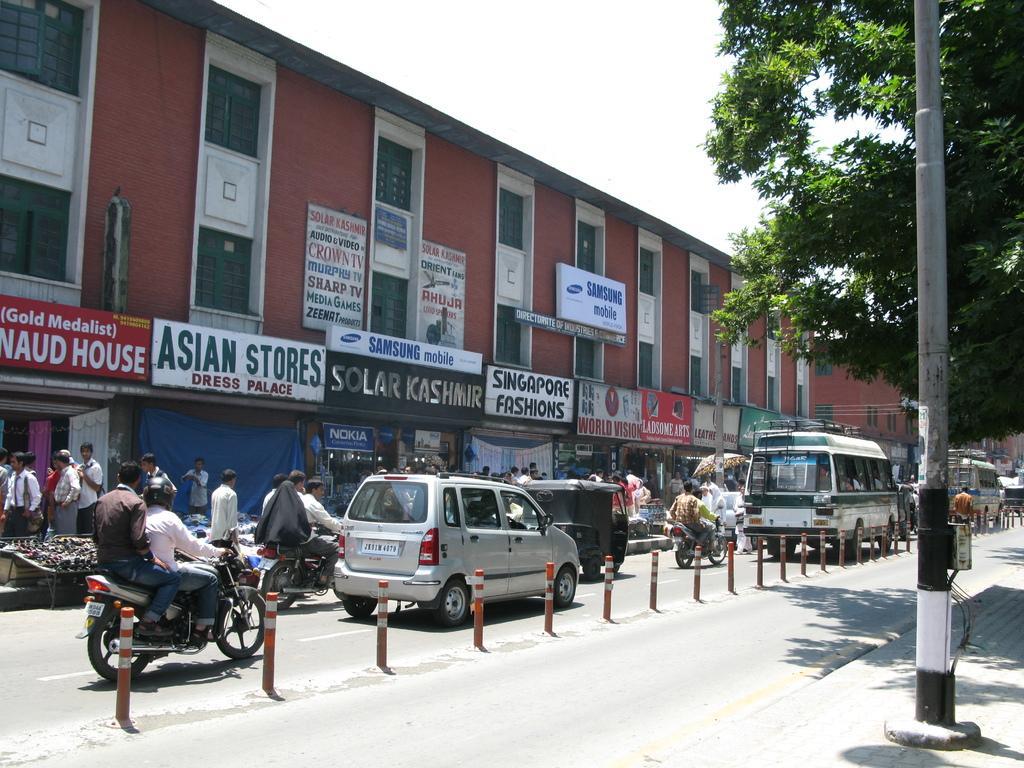In one or two sentences, can you explain what this image depicts? In this picture I can see the road in the center, on which I see number of vehicles and I see few people. In the background I see number of buildings on which there are boards and I see something is written on it and on the right side of this image I see the trees and I see a pole and I see the sky on the top of this image. 